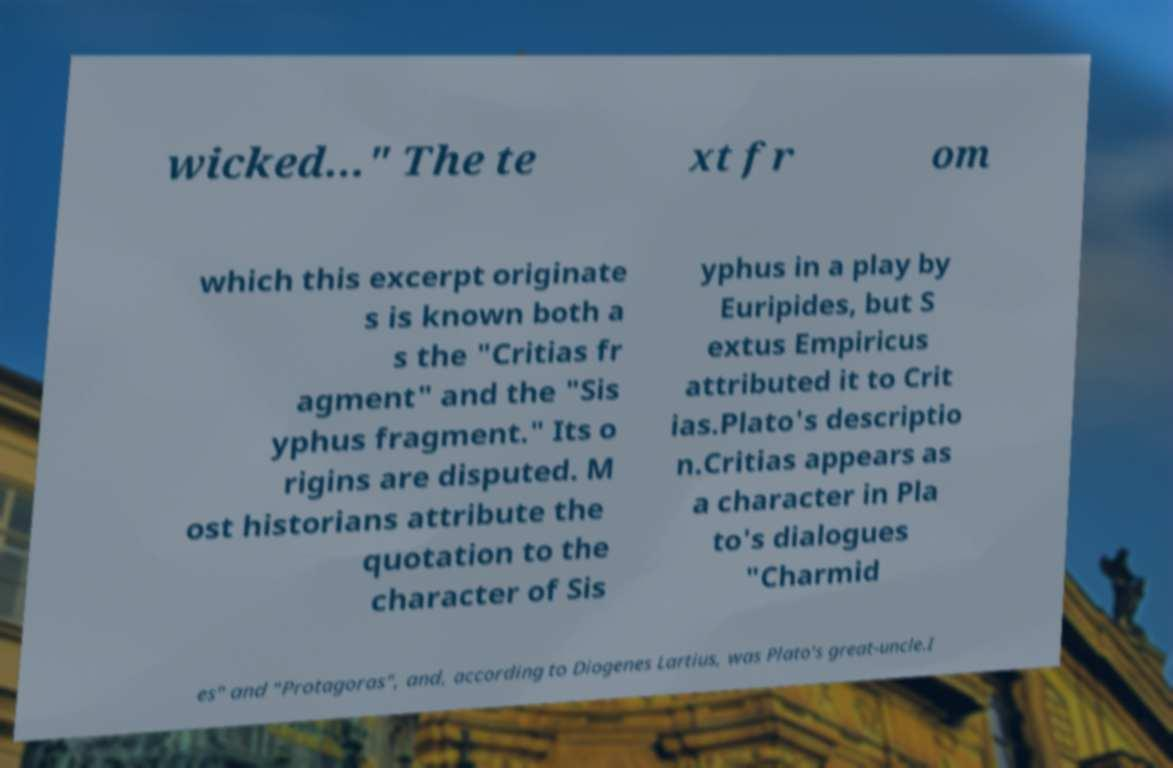What messages or text are displayed in this image? I need them in a readable, typed format. wicked..." The te xt fr om which this excerpt originate s is known both a s the "Critias fr agment" and the "Sis yphus fragment." Its o rigins are disputed. M ost historians attribute the quotation to the character of Sis yphus in a play by Euripides, but S extus Empiricus attributed it to Crit ias.Plato's descriptio n.Critias appears as a character in Pla to's dialogues "Charmid es" and "Protagoras", and, according to Diogenes Lartius, was Plato's great-uncle.I 